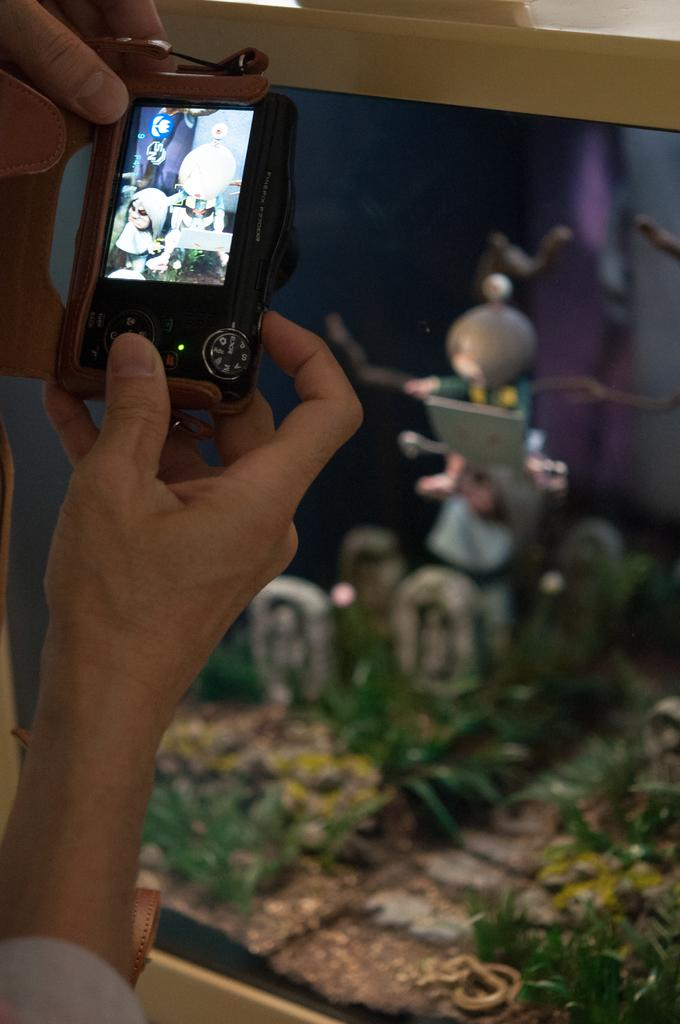What is the person in the image holding? The person in the image is holding a camera. What can be seen in the background of the image? There are green color things in the background of the image. How would you describe the quality of the image? The image is slightly blurry in the background. Reasoning: Let' Let's think step by step in order to produce the conversation. We start by identifying the main subject in the image, which is the person holding a camera. Then, we expand the conversation to include details about the background, such as the presence of green color things and the slight blurriness. Each question is designed to elicit a specific detail about the image that is known from the provided facts. Absurd Question/Answer: What type of crayon is the person using to draw in the image? There is no crayon or drawing activity present in the image; the person is holding a camera. How many bears are visible in the image? There are no bears present in the image. What type of crayon is the person using to draw in the image? There is no crayon or drawing activity present in the image; the person is holding a camera. How many bears are visible in the image? There are no bears present in the image. 